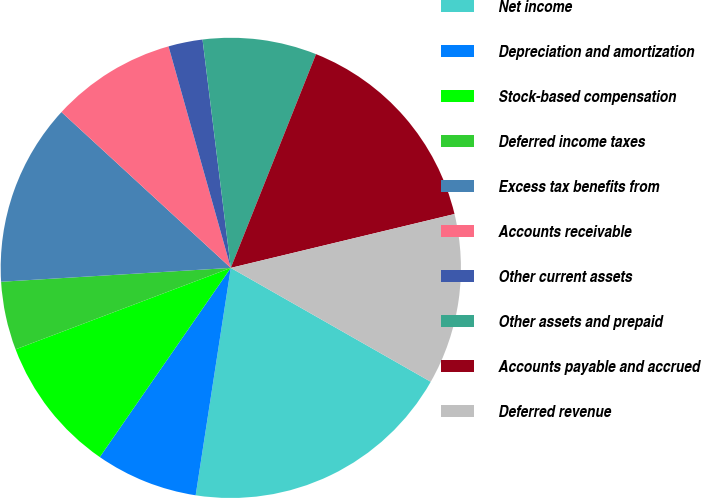Convert chart to OTSL. <chart><loc_0><loc_0><loc_500><loc_500><pie_chart><fcel>Net income<fcel>Depreciation and amortization<fcel>Stock-based compensation<fcel>Deferred income taxes<fcel>Excess tax benefits from<fcel>Accounts receivable<fcel>Other current assets<fcel>Other assets and prepaid<fcel>Accounts payable and accrued<fcel>Deferred revenue<nl><fcel>19.2%<fcel>7.2%<fcel>9.6%<fcel>4.8%<fcel>12.8%<fcel>8.8%<fcel>2.4%<fcel>8.0%<fcel>15.2%<fcel>12.0%<nl></chart> 